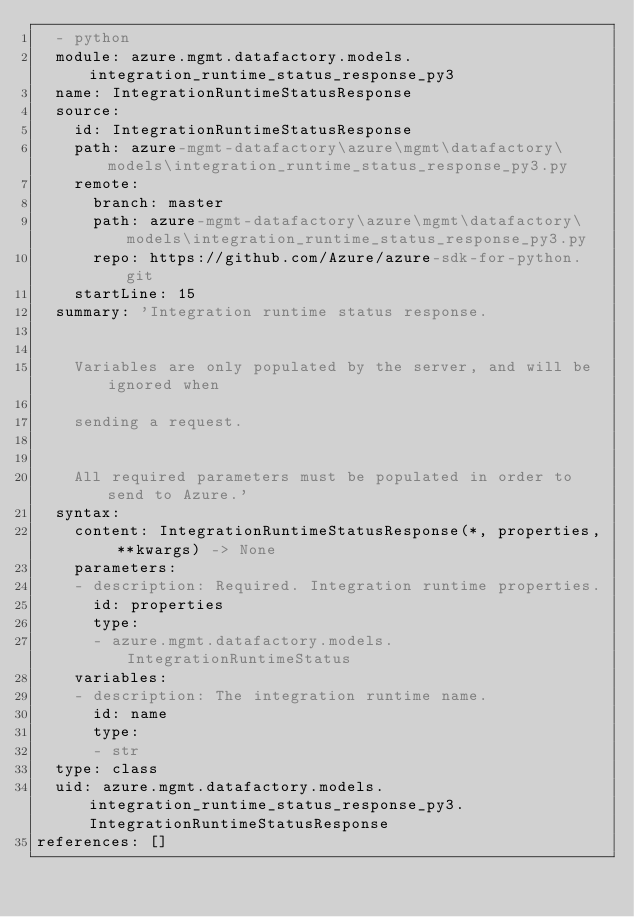<code> <loc_0><loc_0><loc_500><loc_500><_YAML_>  - python
  module: azure.mgmt.datafactory.models.integration_runtime_status_response_py3
  name: IntegrationRuntimeStatusResponse
  source:
    id: IntegrationRuntimeStatusResponse
    path: azure-mgmt-datafactory\azure\mgmt\datafactory\models\integration_runtime_status_response_py3.py
    remote:
      branch: master
      path: azure-mgmt-datafactory\azure\mgmt\datafactory\models\integration_runtime_status_response_py3.py
      repo: https://github.com/Azure/azure-sdk-for-python.git
    startLine: 15
  summary: 'Integration runtime status response.


    Variables are only populated by the server, and will be ignored when

    sending a request.


    All required parameters must be populated in order to send to Azure.'
  syntax:
    content: IntegrationRuntimeStatusResponse(*, properties, **kwargs) -> None
    parameters:
    - description: Required. Integration runtime properties.
      id: properties
      type:
      - azure.mgmt.datafactory.models.IntegrationRuntimeStatus
    variables:
    - description: The integration runtime name.
      id: name
      type:
      - str
  type: class
  uid: azure.mgmt.datafactory.models.integration_runtime_status_response_py3.IntegrationRuntimeStatusResponse
references: []
</code> 